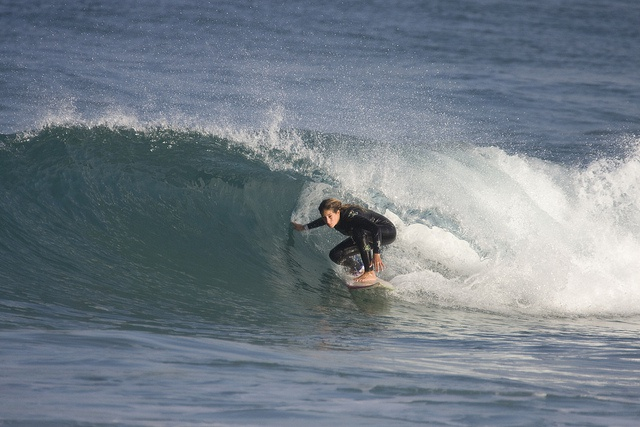Describe the objects in this image and their specific colors. I can see people in blue, black, gray, darkgray, and tan tones and surfboard in blue, gray, lightgray, and darkgray tones in this image. 